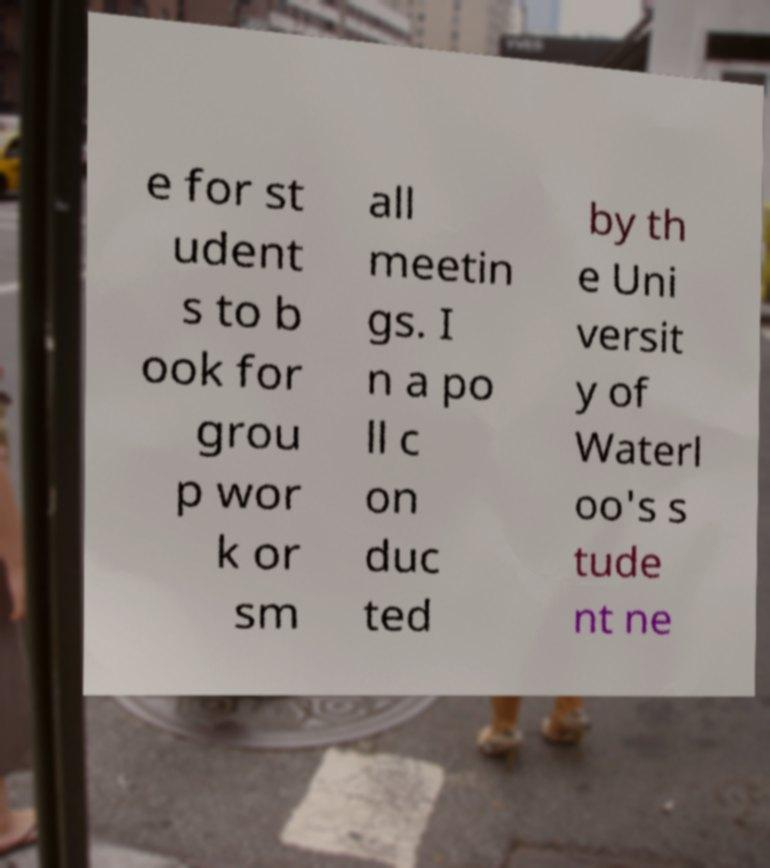For documentation purposes, I need the text within this image transcribed. Could you provide that? e for st udent s to b ook for grou p wor k or sm all meetin gs. I n a po ll c on duc ted by th e Uni versit y of Waterl oo's s tude nt ne 